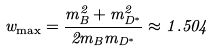Convert formula to latex. <formula><loc_0><loc_0><loc_500><loc_500>w _ { \max } = \frac { m _ { B } ^ { 2 } + m _ { D ^ { * } } ^ { 2 } } { 2 m _ { B } m _ { D ^ { * } } } \approx 1 . 5 0 4</formula> 